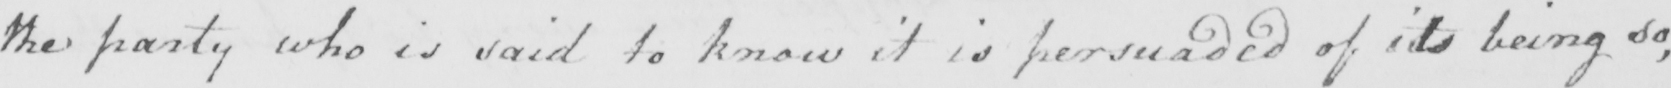Can you read and transcribe this handwriting? the party who is said to know it is persuaded of its being so , 